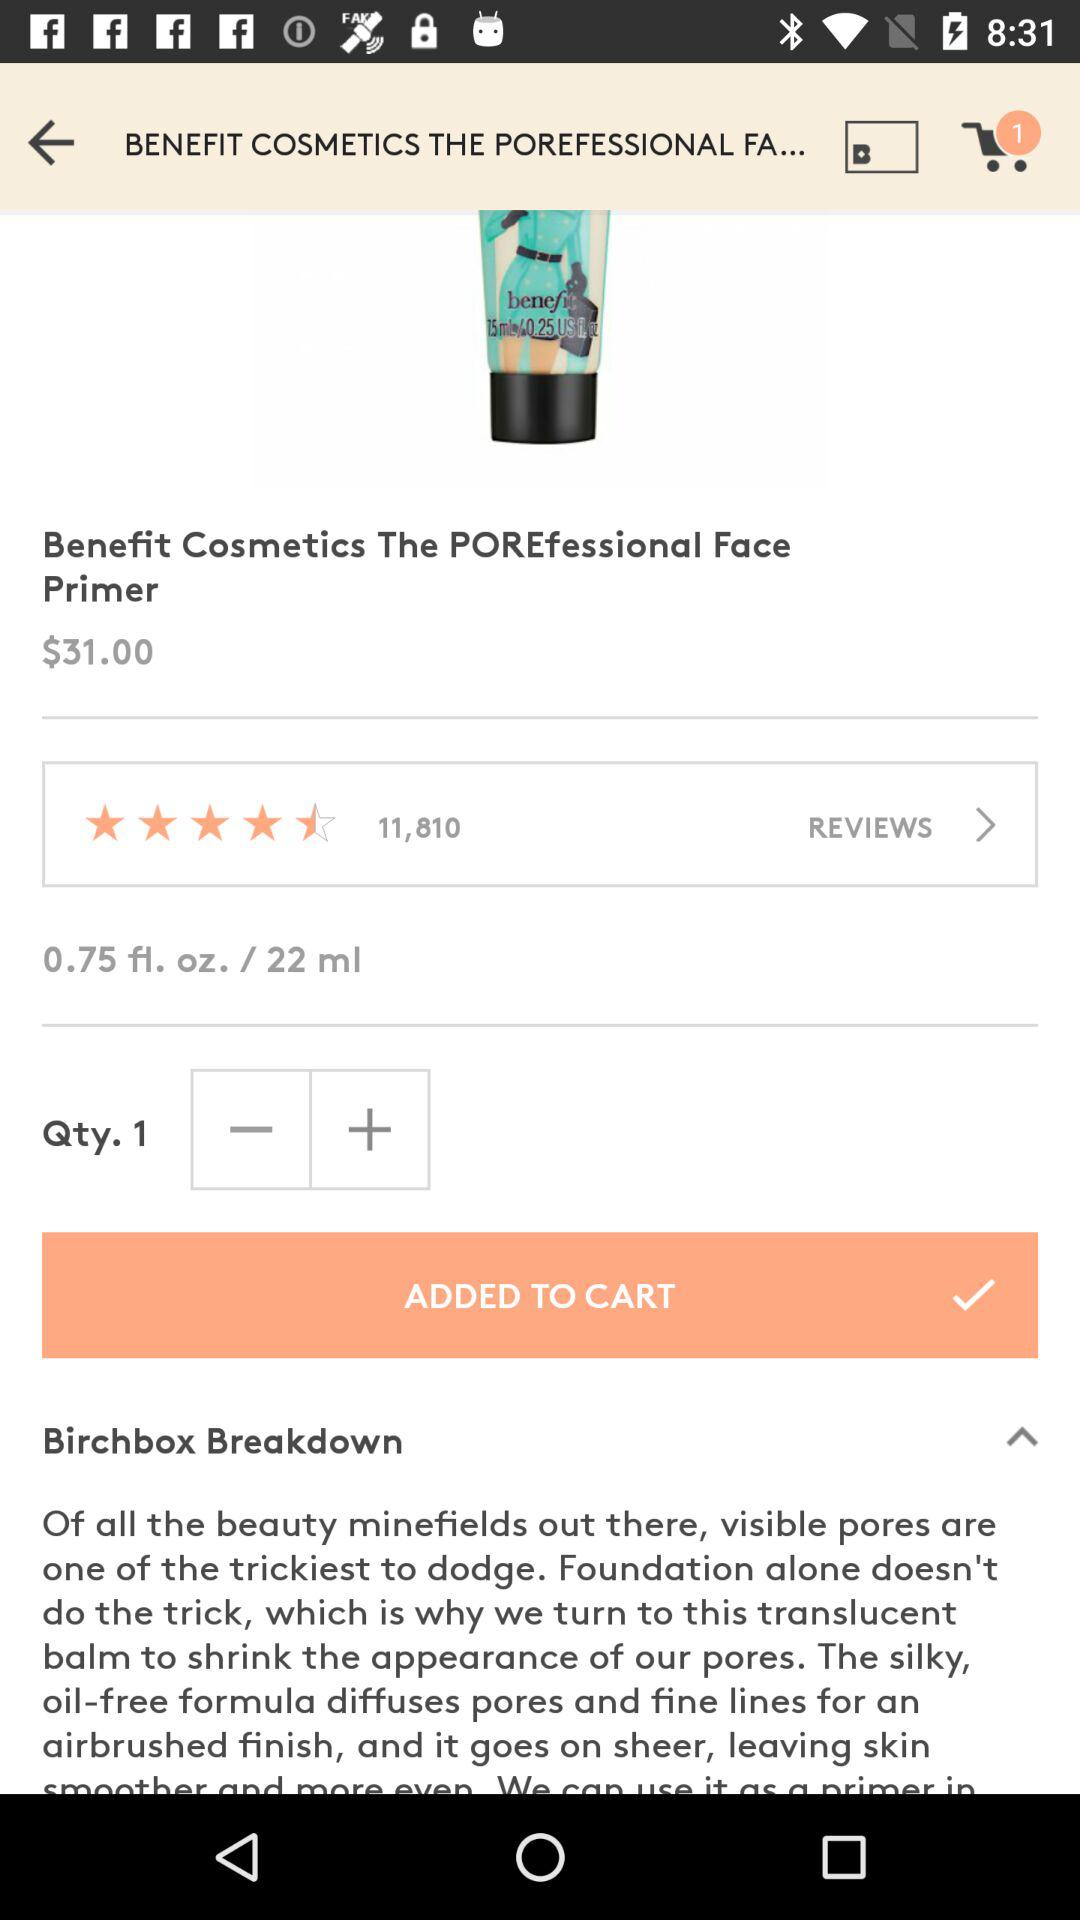How many people have reviewed the product? The product has been reviewed by 11,810 people. 